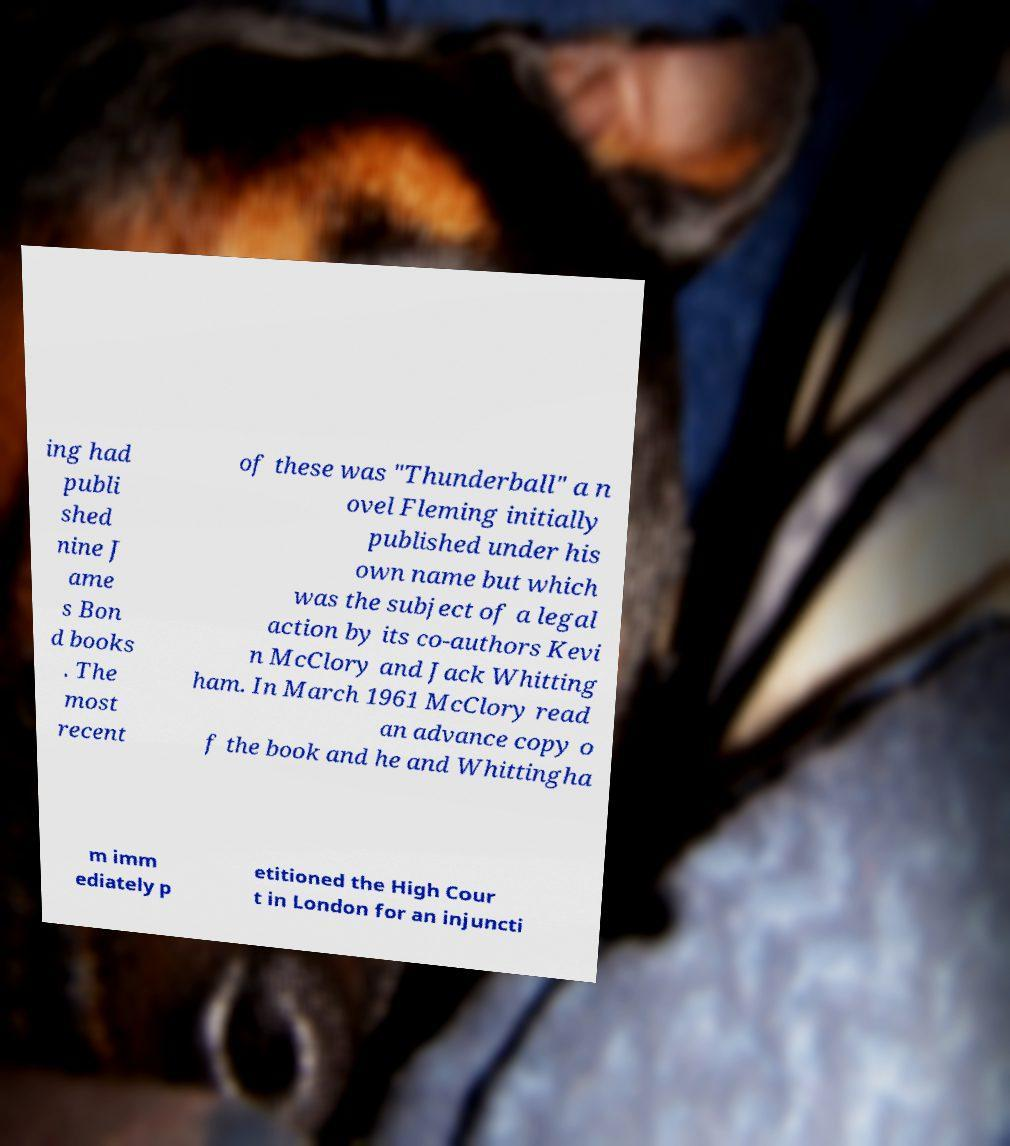Can you accurately transcribe the text from the provided image for me? ing had publi shed nine J ame s Bon d books . The most recent of these was "Thunderball" a n ovel Fleming initially published under his own name but which was the subject of a legal action by its co-authors Kevi n McClory and Jack Whitting ham. In March 1961 McClory read an advance copy o f the book and he and Whittingha m imm ediately p etitioned the High Cour t in London for an injuncti 